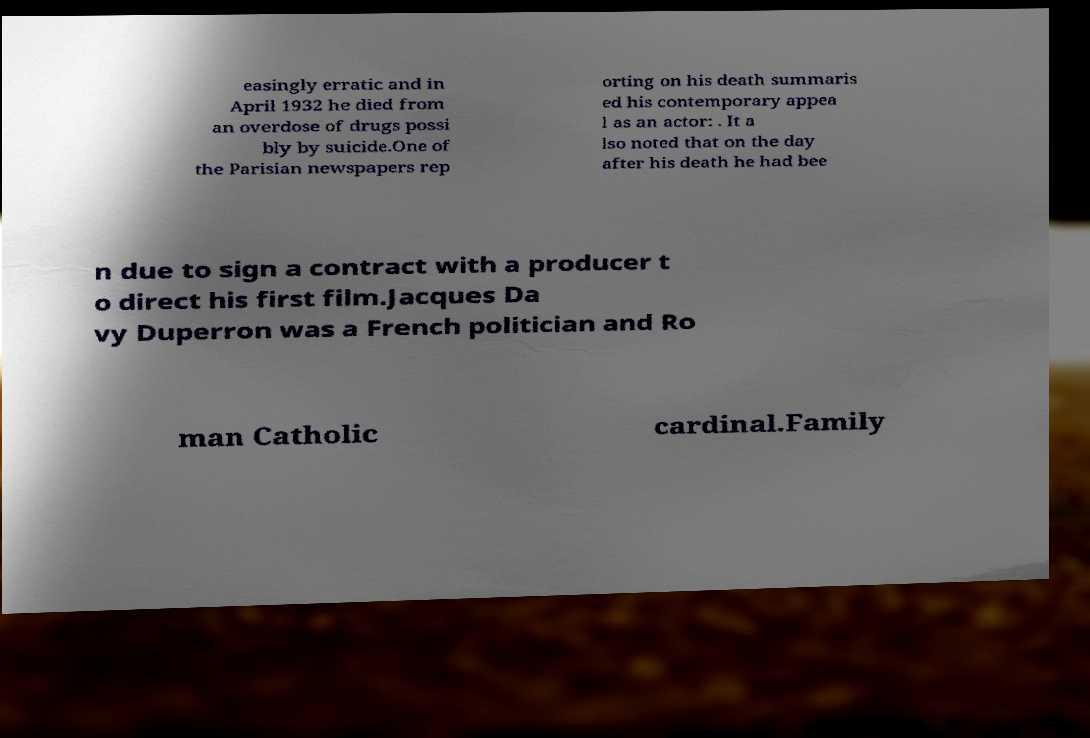For documentation purposes, I need the text within this image transcribed. Could you provide that? easingly erratic and in April 1932 he died from an overdose of drugs possi bly by suicide.One of the Parisian newspapers rep orting on his death summaris ed his contemporary appea l as an actor: . It a lso noted that on the day after his death he had bee n due to sign a contract with a producer t o direct his first film.Jacques Da vy Duperron was a French politician and Ro man Catholic cardinal.Family 